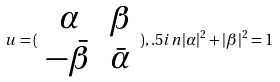<formula> <loc_0><loc_0><loc_500><loc_500>u = ( \begin{array} { c c } \alpha & \beta \\ - \bar { \beta } & \bar { \alpha } \end{array} ) , . 5 i n | \alpha | ^ { 2 } + | \beta | ^ { 2 } = 1</formula> 